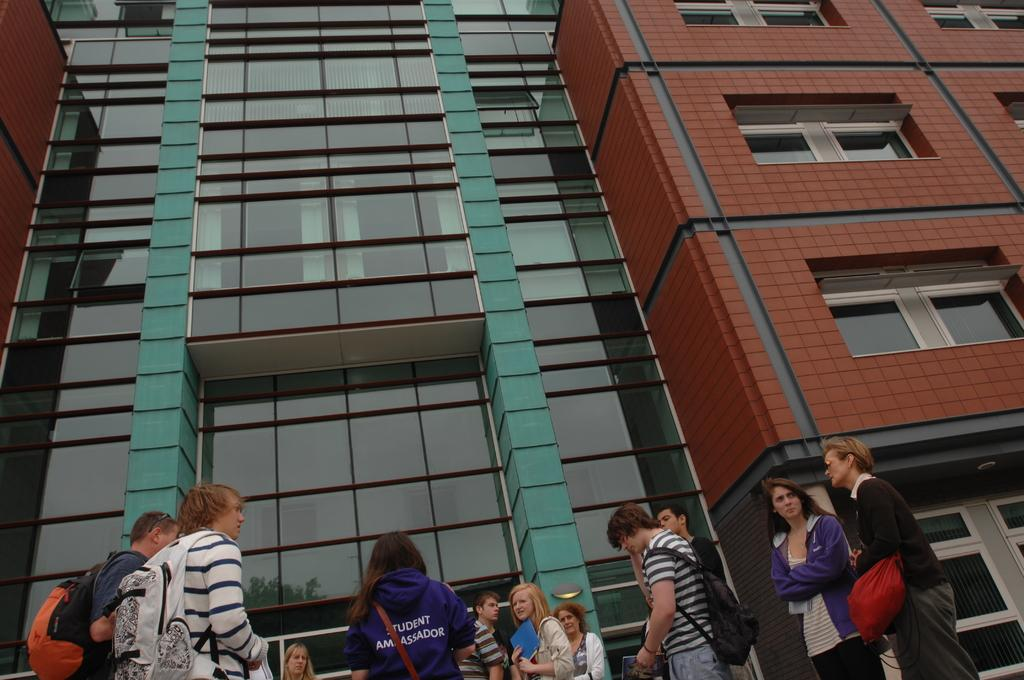How many people are in the image? There is a group of people standing in the image. What can be seen in the background of the image? There is a building in the background of the image. What is reflected on the mirror in the image? There is a reflection of a tree on a mirror in the image. What type of chain is being exchanged between the people in the image? There is no chain or exchange of any kind depicted in the image. 